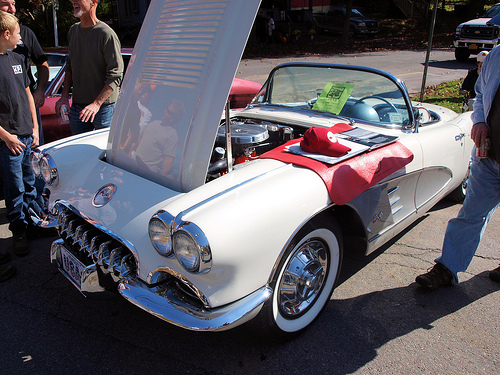<image>
Is there a cap next to the car? No. The cap is not positioned next to the car. They are located in different areas of the scene. 